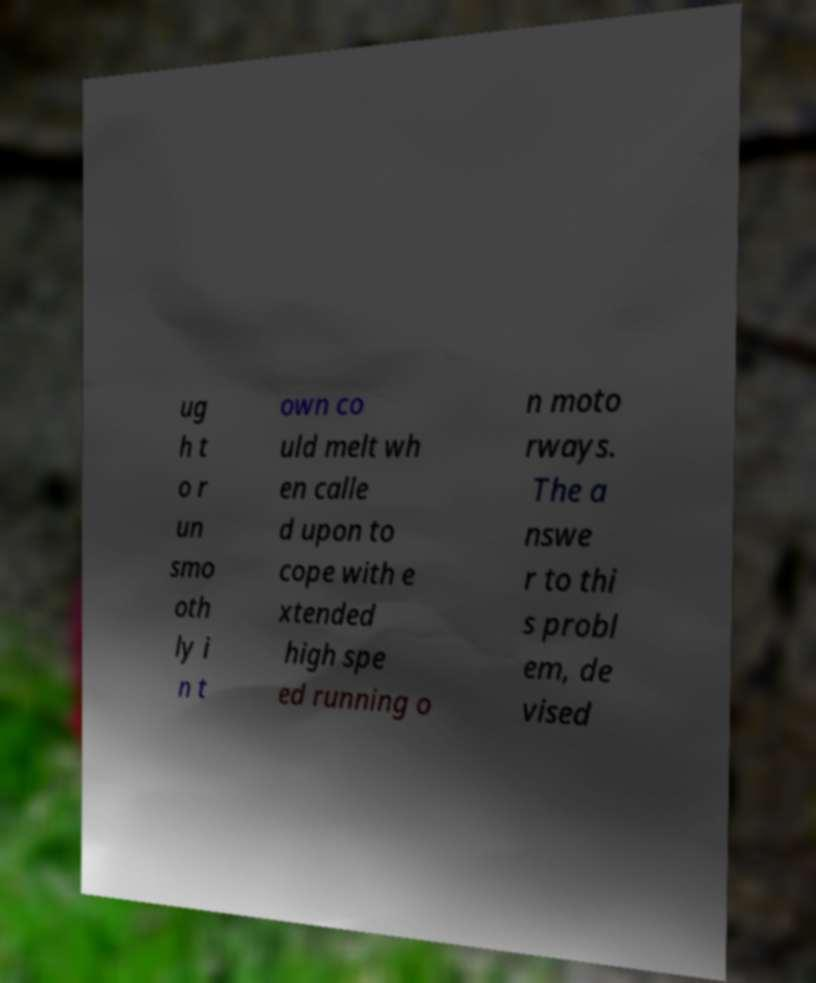Can you accurately transcribe the text from the provided image for me? ug h t o r un smo oth ly i n t own co uld melt wh en calle d upon to cope with e xtended high spe ed running o n moto rways. The a nswe r to thi s probl em, de vised 